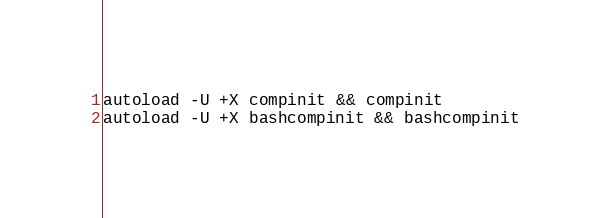Convert code to text. <code><loc_0><loc_0><loc_500><loc_500><_Bash_>autoload -U +X compinit && compinit
autoload -U +X bashcompinit && bashcompinit</code> 